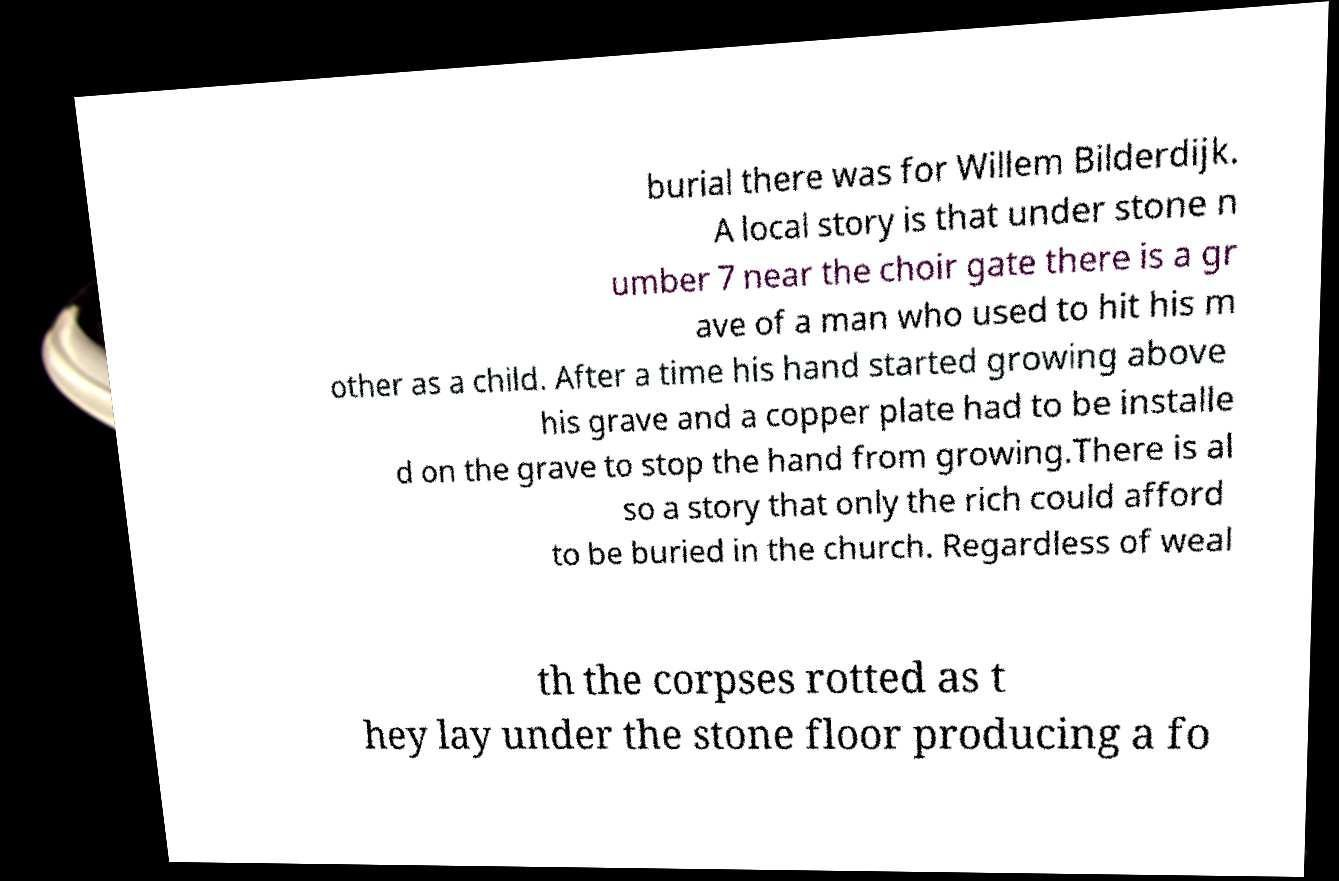What messages or text are displayed in this image? I need them in a readable, typed format. burial there was for Willem Bilderdijk. A local story is that under stone n umber 7 near the choir gate there is a gr ave of a man who used to hit his m other as a child. After a time his hand started growing above his grave and a copper plate had to be installe d on the grave to stop the hand from growing.There is al so a story that only the rich could afford to be buried in the church. Regardless of weal th the corpses rotted as t hey lay under the stone floor producing a fo 